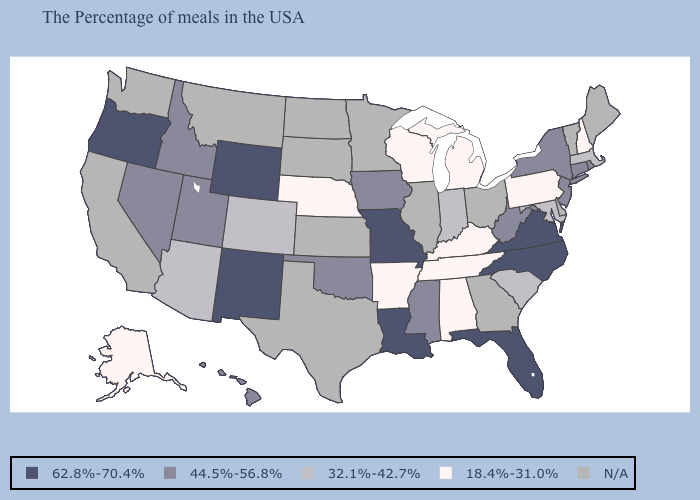What is the lowest value in the USA?
Short answer required. 18.4%-31.0%. What is the value of Virginia?
Write a very short answer. 62.8%-70.4%. Among the states that border Massachusetts , does New York have the highest value?
Concise answer only. Yes. Which states have the lowest value in the South?
Answer briefly. Kentucky, Alabama, Tennessee, Arkansas. What is the highest value in the MidWest ?
Be succinct. 62.8%-70.4%. What is the value of Louisiana?
Be succinct. 62.8%-70.4%. Among the states that border Minnesota , does Iowa have the lowest value?
Write a very short answer. No. Name the states that have a value in the range 62.8%-70.4%?
Be succinct. Virginia, North Carolina, Florida, Louisiana, Missouri, Wyoming, New Mexico, Oregon. What is the value of Indiana?
Short answer required. 32.1%-42.7%. Name the states that have a value in the range 62.8%-70.4%?
Be succinct. Virginia, North Carolina, Florida, Louisiana, Missouri, Wyoming, New Mexico, Oregon. Among the states that border Ohio , does Kentucky have the highest value?
Answer briefly. No. What is the lowest value in the Northeast?
Quick response, please. 18.4%-31.0%. What is the lowest value in the USA?
Write a very short answer. 18.4%-31.0%. Name the states that have a value in the range 62.8%-70.4%?
Concise answer only. Virginia, North Carolina, Florida, Louisiana, Missouri, Wyoming, New Mexico, Oregon. 